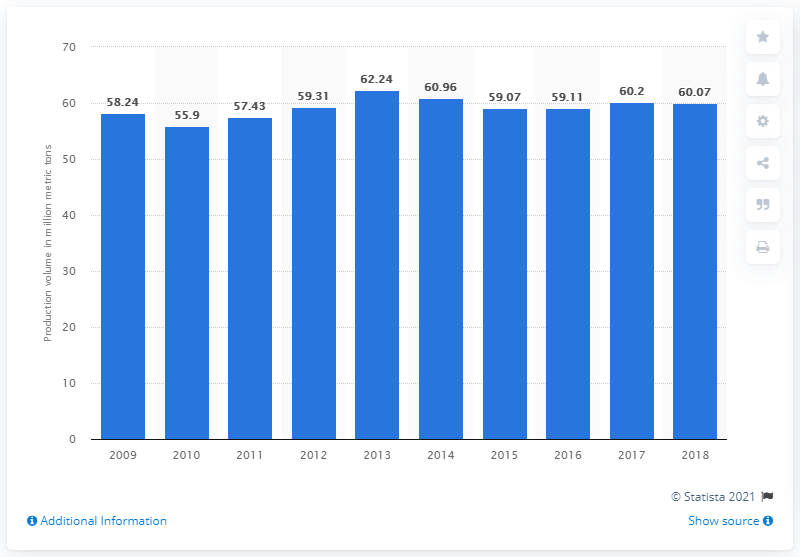Draw attention to some important aspects in this diagram. In fiscal year 2018, the production volume of cement in Japan was 60,070,000 units. 